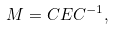Convert formula to latex. <formula><loc_0><loc_0><loc_500><loc_500>M = C E C ^ { - 1 } ,</formula> 